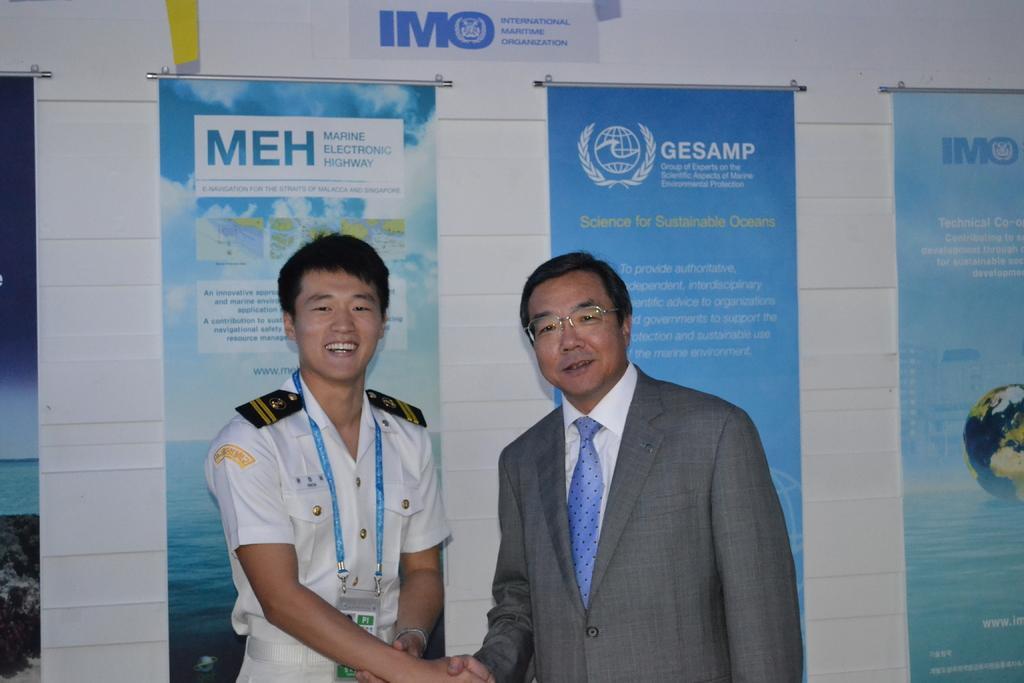Describe this image in one or two sentences. In the front of the image I can see two people are smiling and giving each other a handshake. In the background of the image there are banners, poster and wall. Something is written on the banners and poster.   